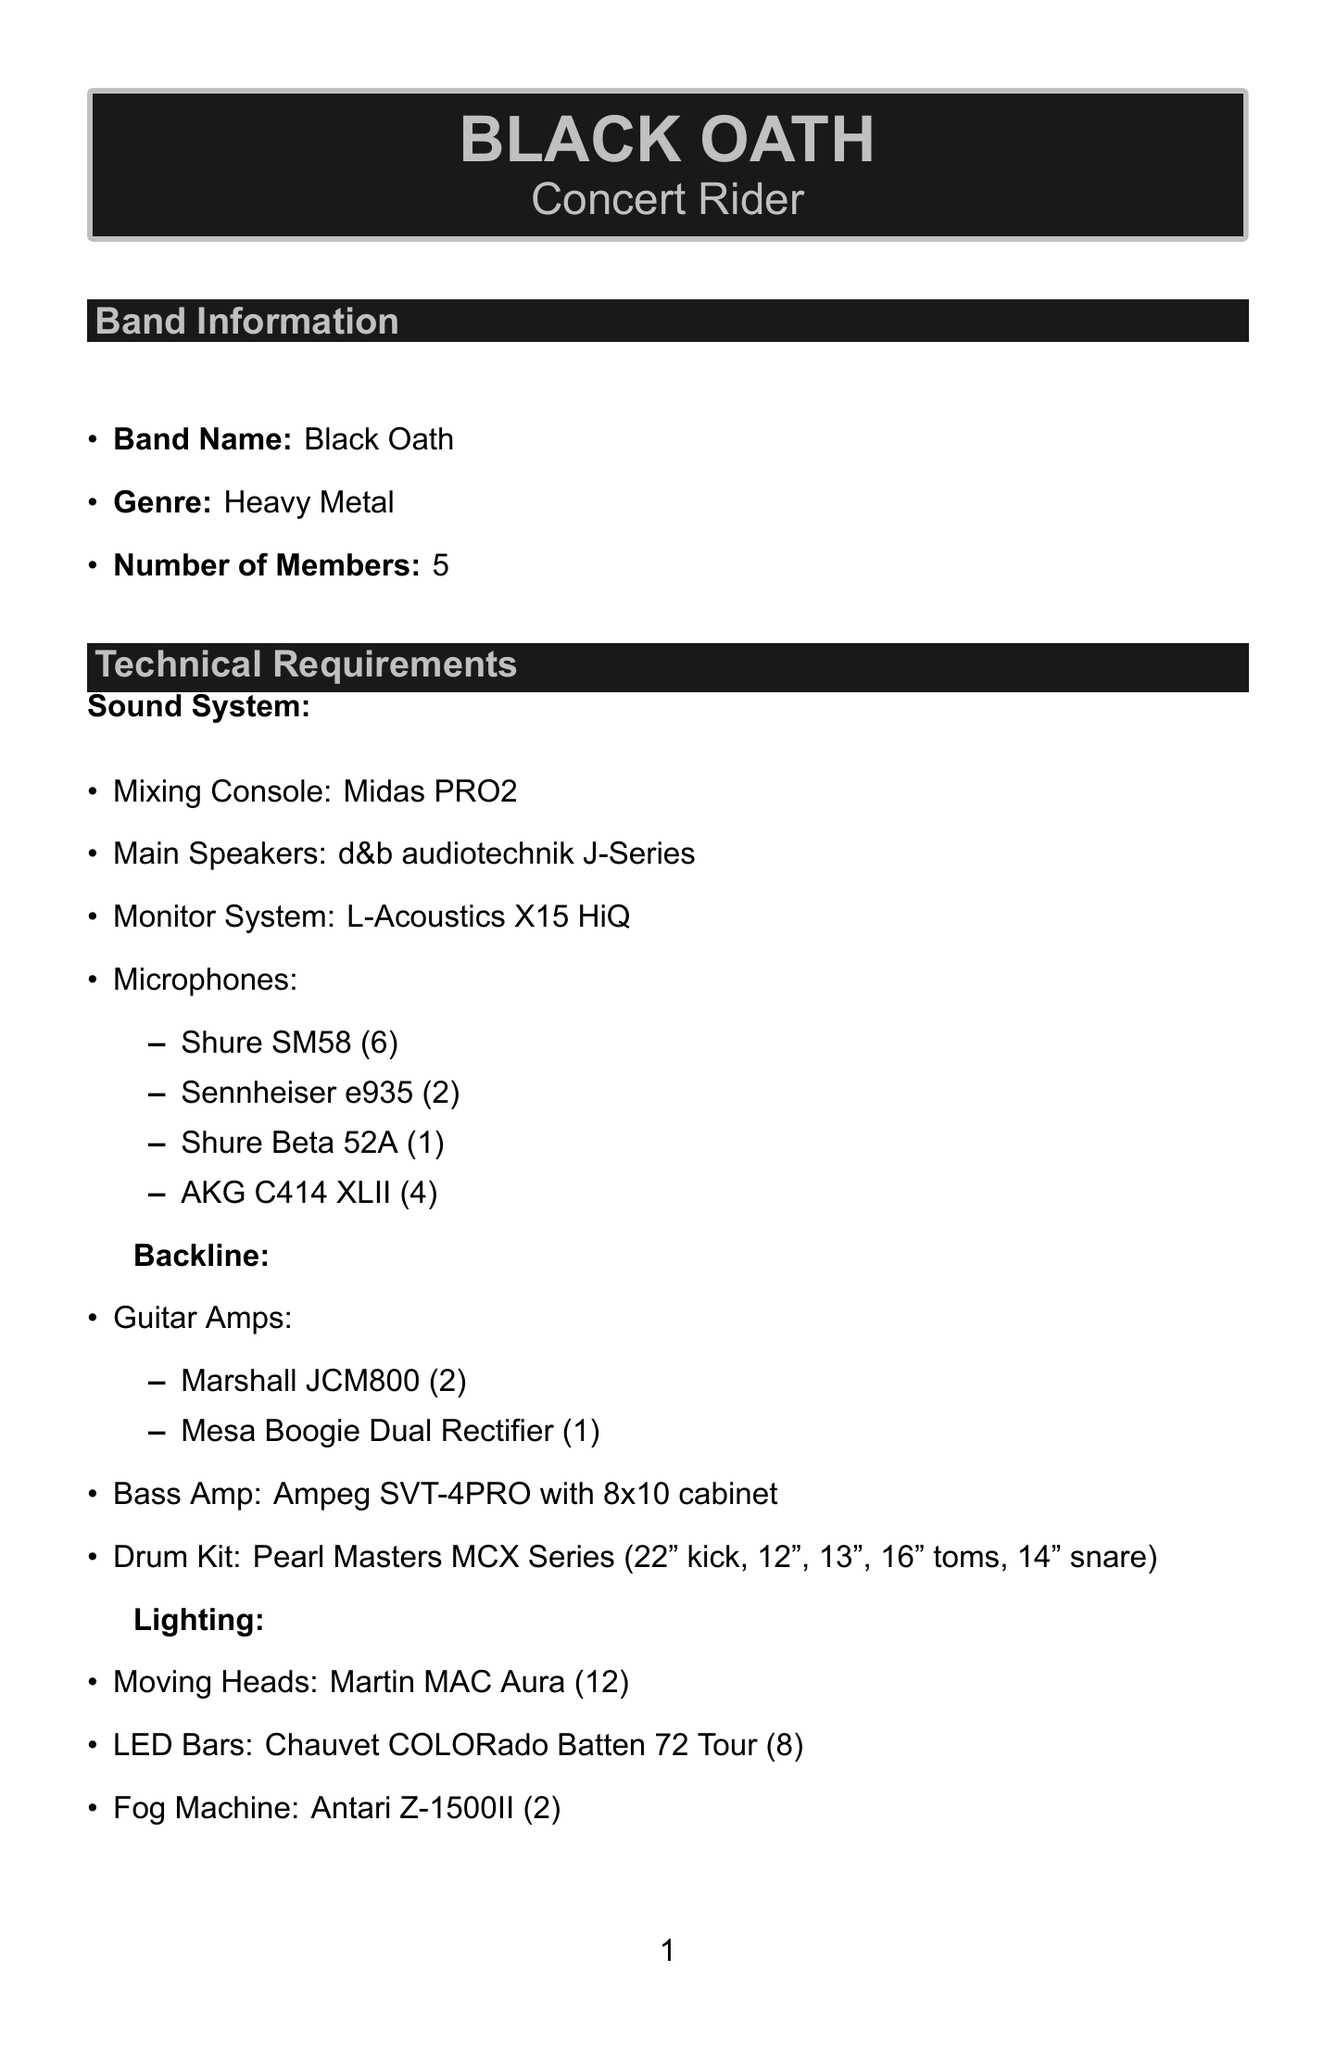What is the genre of the band? The genre of Black Oath is classified as Heavy Metal.
Answer: Heavy Metal How many members are in Black Oath? The document states that Black Oath consists of five members.
Answer: 5 What type of mixing console is required? The sound system section lists Midas PRO2 as the required mixing console.
Answer: Midas PRO2 How many security personnel are needed during the performance? The security section notes that two personnel are required on stage during the performance.
Answer: 2 What is the size of the stage required? The stage plot specifies a minimum stage size of 30 feet by 20 feet.
Answer: minimum 30ft x 20ft What is included in the catering for lunch? The catering section mentions that lunch consists of assorted sandwiches and salads.
Answer: Assorted sandwiches and salads How many complimentary tickets are allocated per show? The guest list section reveals that ten complimentary tickets are allocated for each show.
Answer: 10 What is the required number of black hand towels on stage? The backstage requirements state that ten black hand towels are needed for the stage.
Answer: 10 What type of vehicle is needed for transportation? The transportation section states that a 15-passenger van with trailer is required.
Answer: 15-passenger van with trailer 